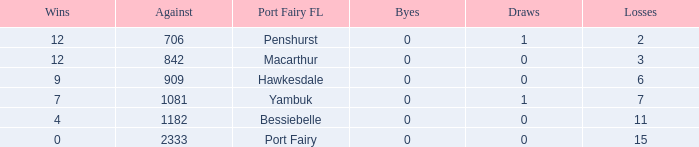How many draws when the Port Fairy FL is Hawkesdale and there are more than 9 wins? None. 